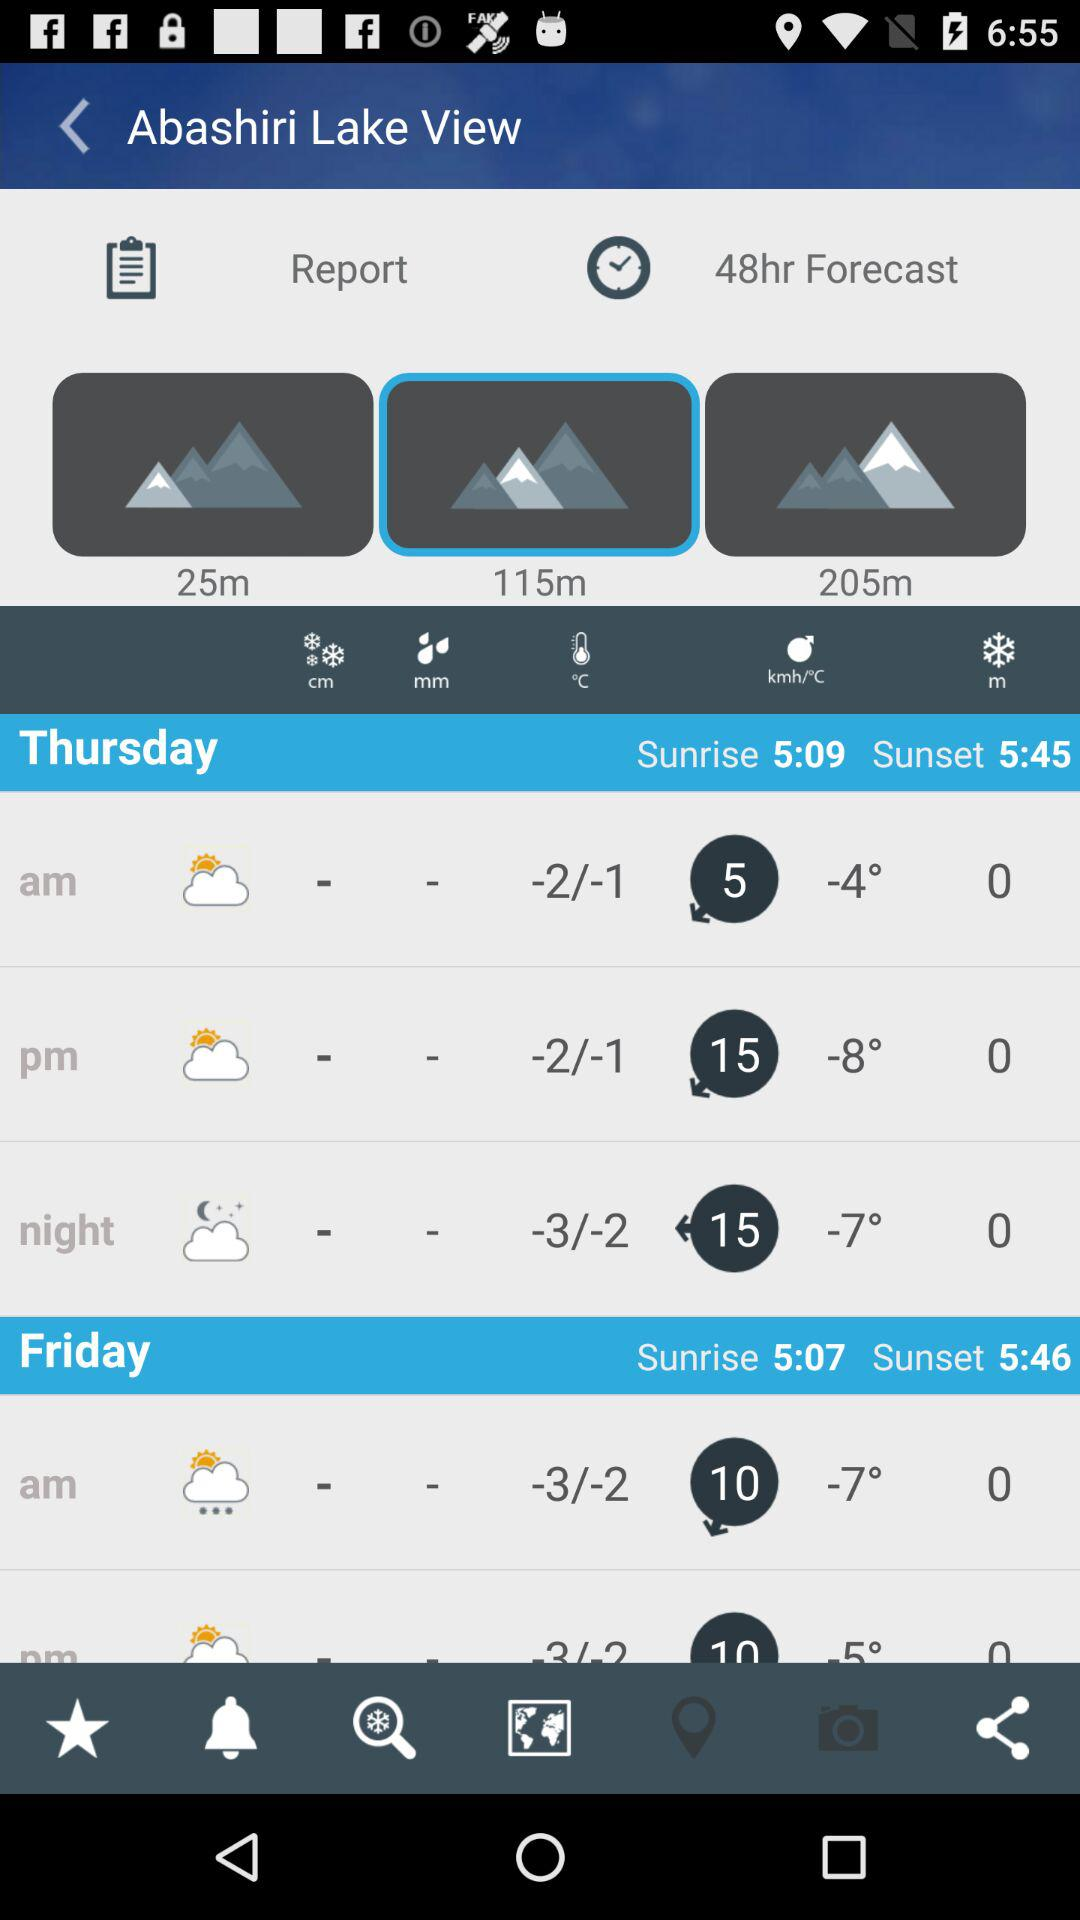What is the sunset time on Thursday? The sunset time on Thursday is 5:45. 